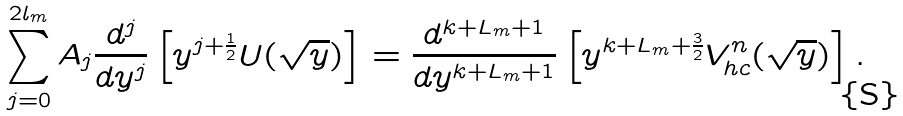<formula> <loc_0><loc_0><loc_500><loc_500>\sum ^ { 2 l _ { m } } _ { j = 0 } A _ { j } \frac { d ^ { j } } { d y ^ { j } } \left [ y ^ { j + \frac { 1 } { 2 } } U ( \sqrt { y } ) \right ] = \frac { d ^ { k + L _ { m } + 1 } } { d y ^ { k + L _ { m } + 1 } } \left [ y ^ { k + L _ { m } + \frac { 3 } { 2 } } V ^ { n } _ { h c } ( \sqrt { y } ) \right ] .</formula> 